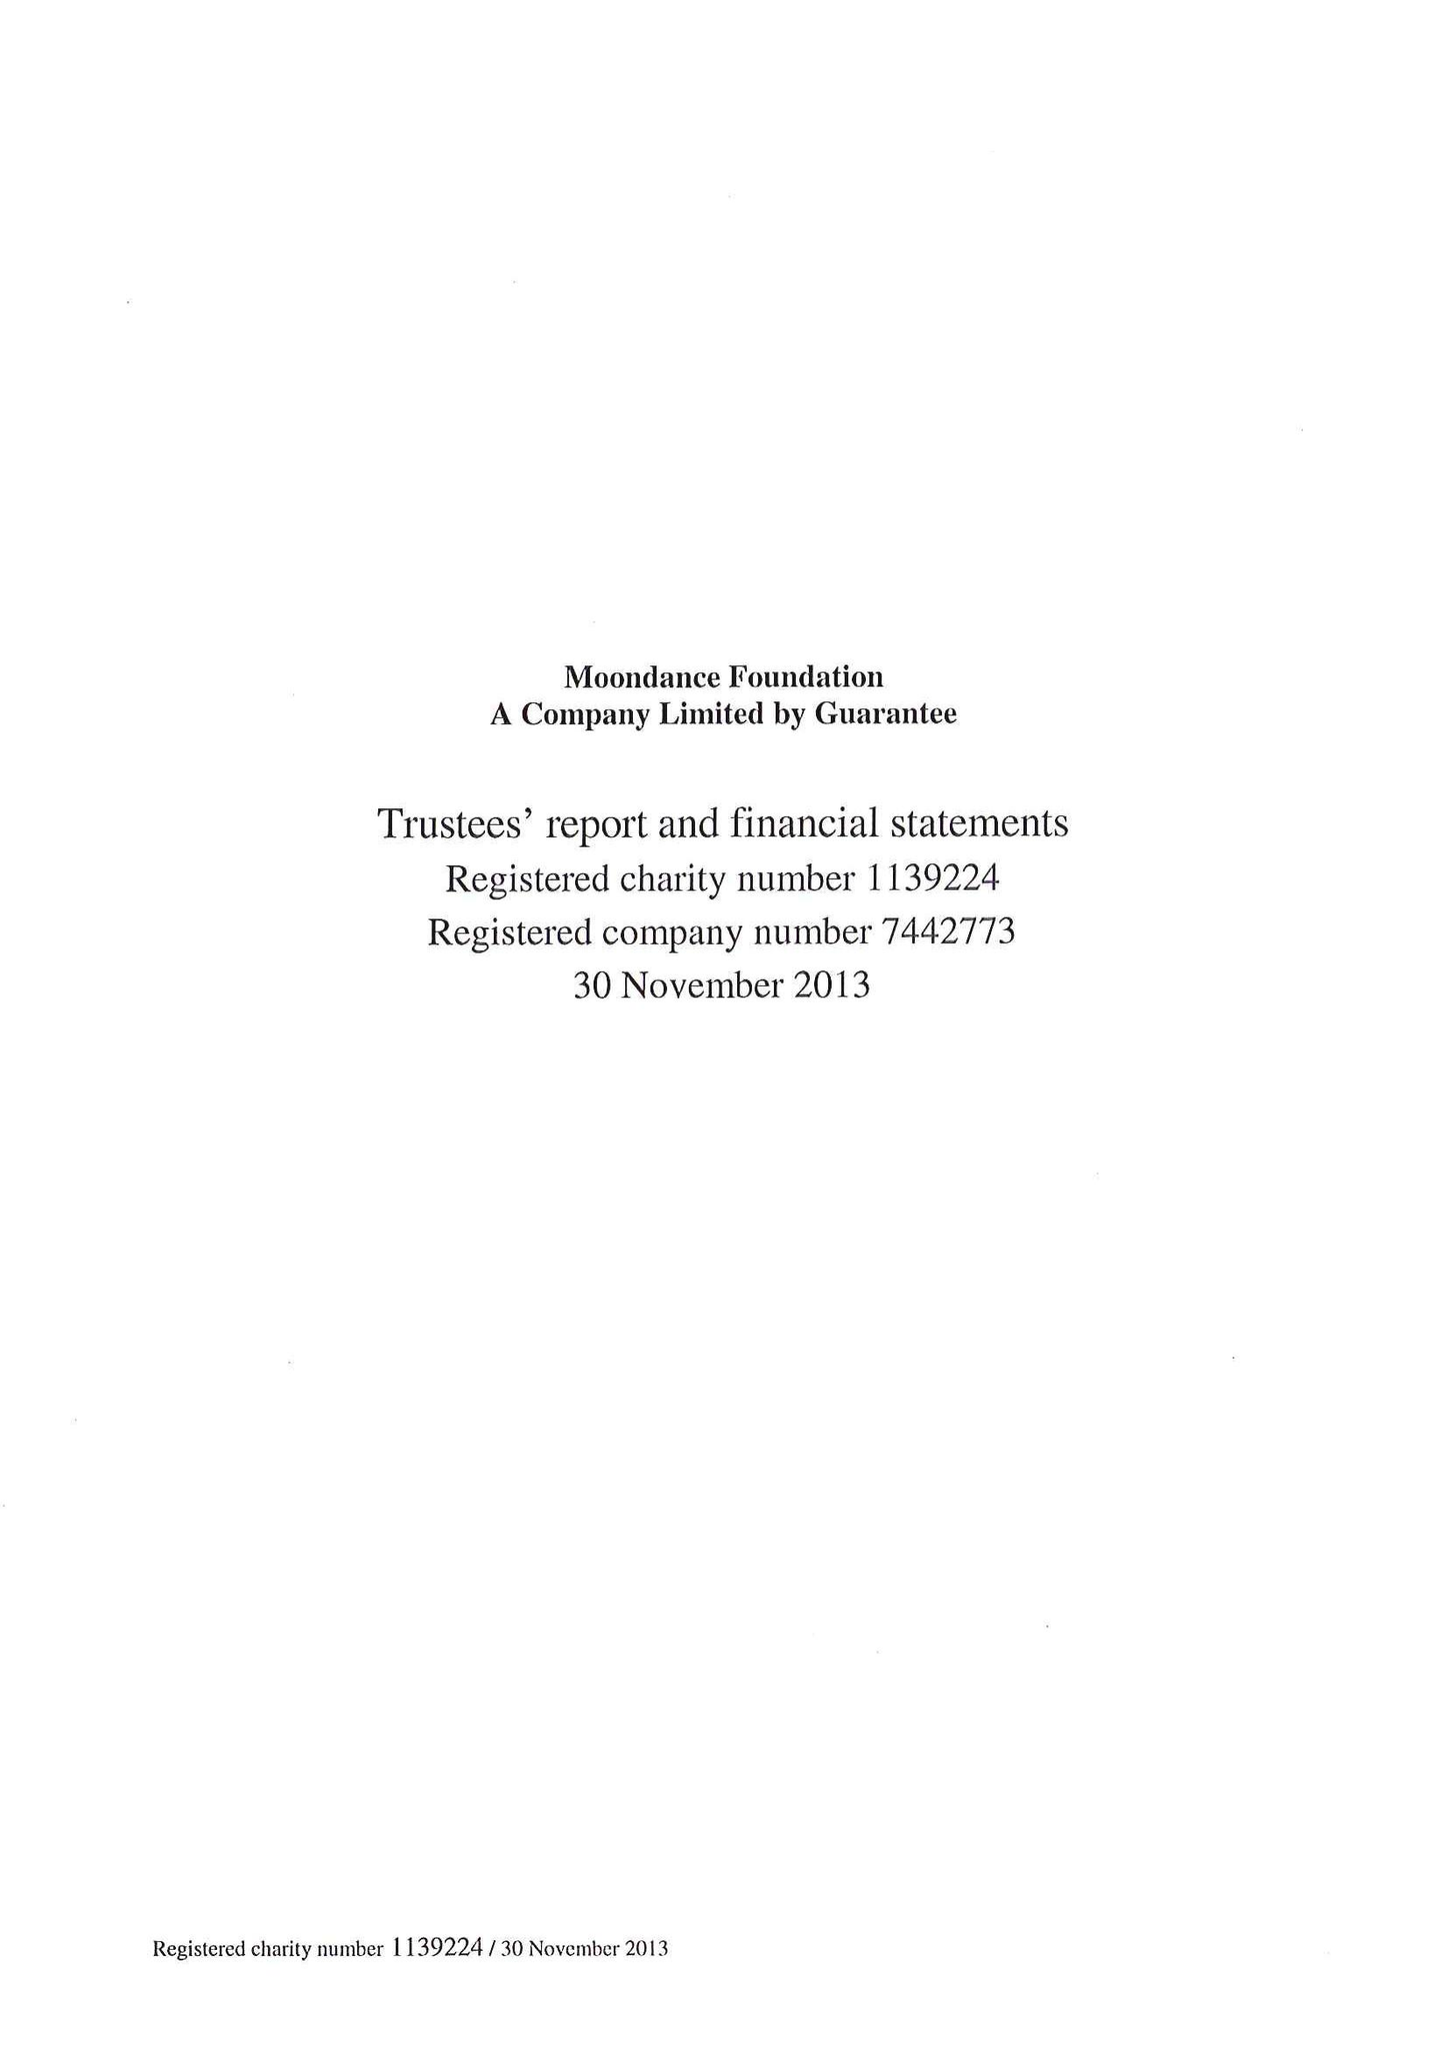What is the value for the spending_annually_in_british_pounds?
Answer the question using a single word or phrase. 4975844.00 